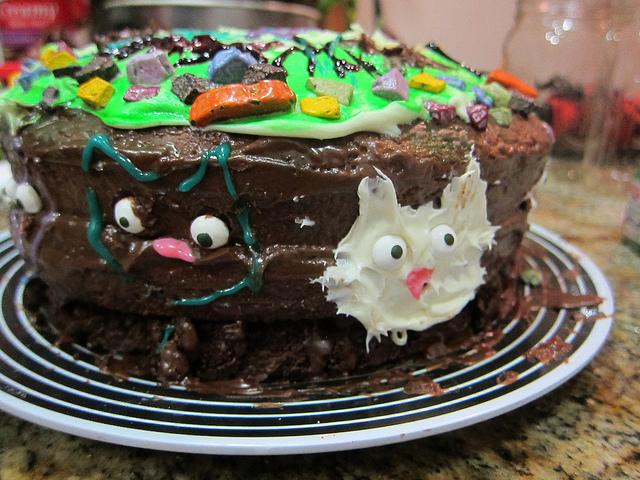Does this cake have frosting cats on it's side?
Keep it brief. Yes. What is the flavor of the frosting?
Give a very brief answer. Chocolate. What is this cake decorated of?
Concise answer only. Cats. 